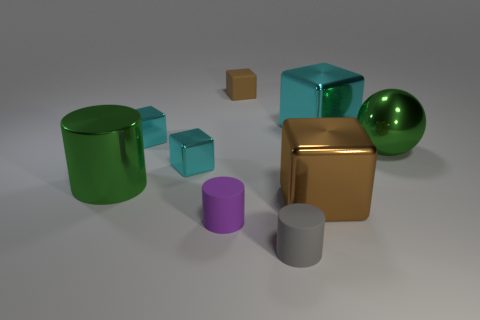Are the cylinder on the right side of the small purple thing and the ball that is right of the tiny brown block made of the same material?
Keep it short and to the point. No. How many things are in front of the shiny cylinder and right of the gray object?
Your response must be concise. 1. Are there any small blue things of the same shape as the large cyan thing?
Make the answer very short. No. What is the shape of the gray rubber thing that is the same size as the brown rubber thing?
Offer a terse response. Cylinder. Are there an equal number of cyan metal blocks behind the small matte cube and small gray rubber cylinders to the right of the gray rubber cylinder?
Give a very brief answer. Yes. There is a green thing that is behind the large object that is to the left of the rubber cube; how big is it?
Your response must be concise. Large. Is there a cyan metal object of the same size as the gray matte thing?
Your response must be concise. Yes. What color is the other cylinder that is made of the same material as the gray cylinder?
Your response must be concise. Purple. Is the number of cyan metal cubes less than the number of purple matte objects?
Your answer should be very brief. No. The cube that is to the left of the gray rubber cylinder and in front of the big metallic ball is made of what material?
Your response must be concise. Metal. 